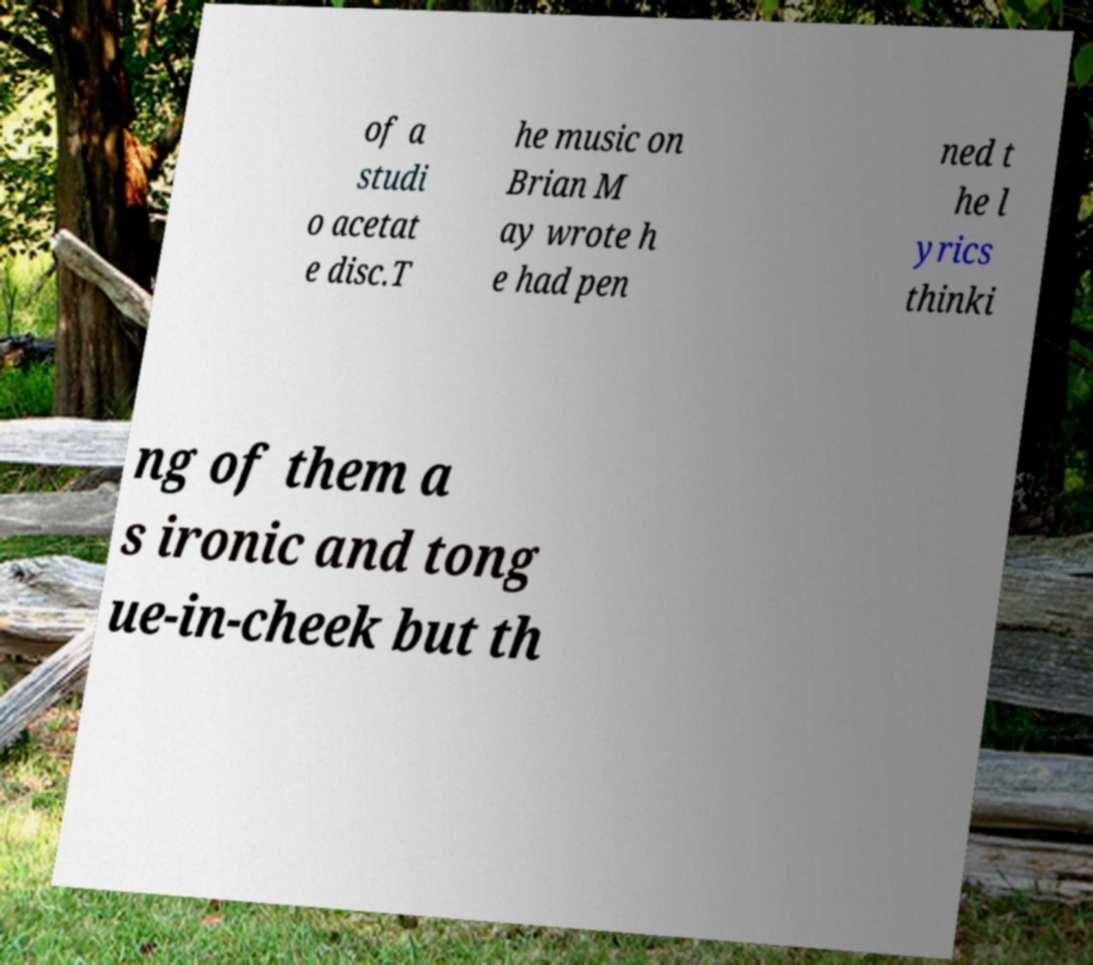Please read and relay the text visible in this image. What does it say? of a studi o acetat e disc.T he music on Brian M ay wrote h e had pen ned t he l yrics thinki ng of them a s ironic and tong ue-in-cheek but th 